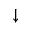<formula> <loc_0><loc_0><loc_500><loc_500>\downarrow</formula> 